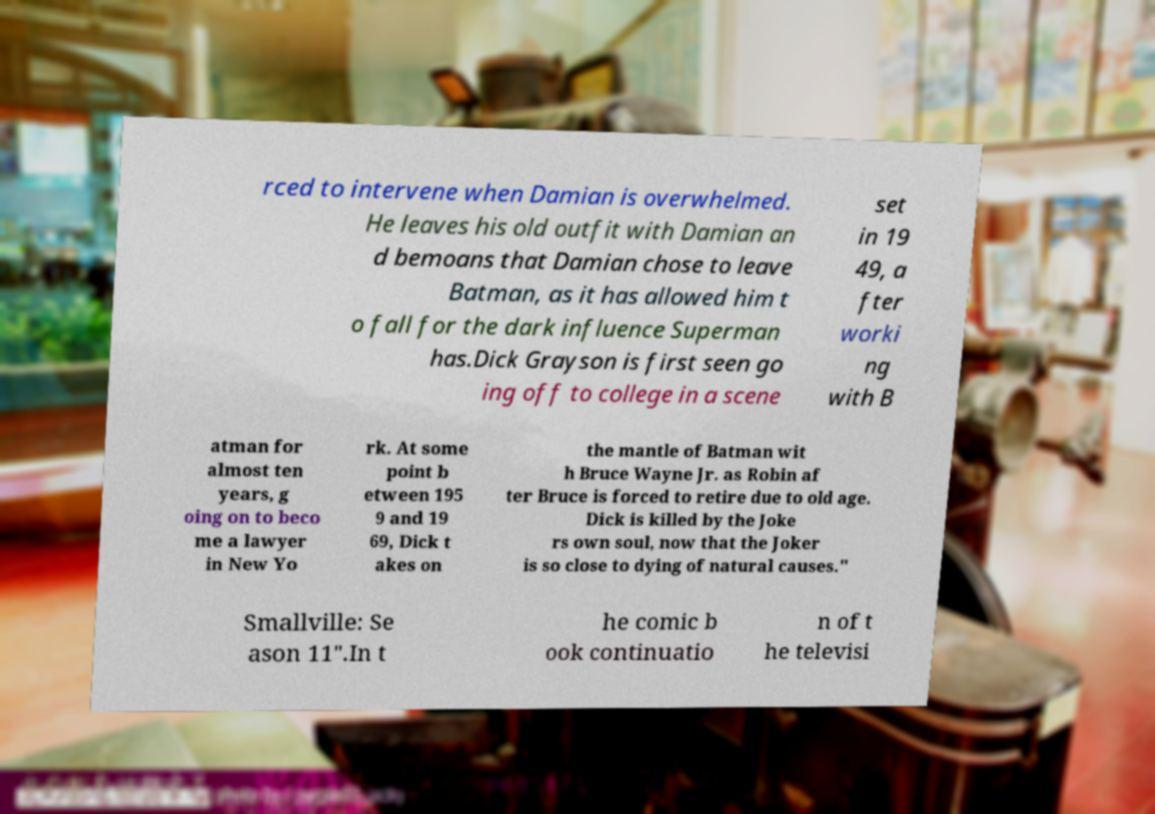Can you accurately transcribe the text from the provided image for me? rced to intervene when Damian is overwhelmed. He leaves his old outfit with Damian an d bemoans that Damian chose to leave Batman, as it has allowed him t o fall for the dark influence Superman has.Dick Grayson is first seen go ing off to college in a scene set in 19 49, a fter worki ng with B atman for almost ten years, g oing on to beco me a lawyer in New Yo rk. At some point b etween 195 9 and 19 69, Dick t akes on the mantle of Batman wit h Bruce Wayne Jr. as Robin af ter Bruce is forced to retire due to old age. Dick is killed by the Joke rs own soul, now that the Joker is so close to dying of natural causes." Smallville: Se ason 11".In t he comic b ook continuatio n of t he televisi 